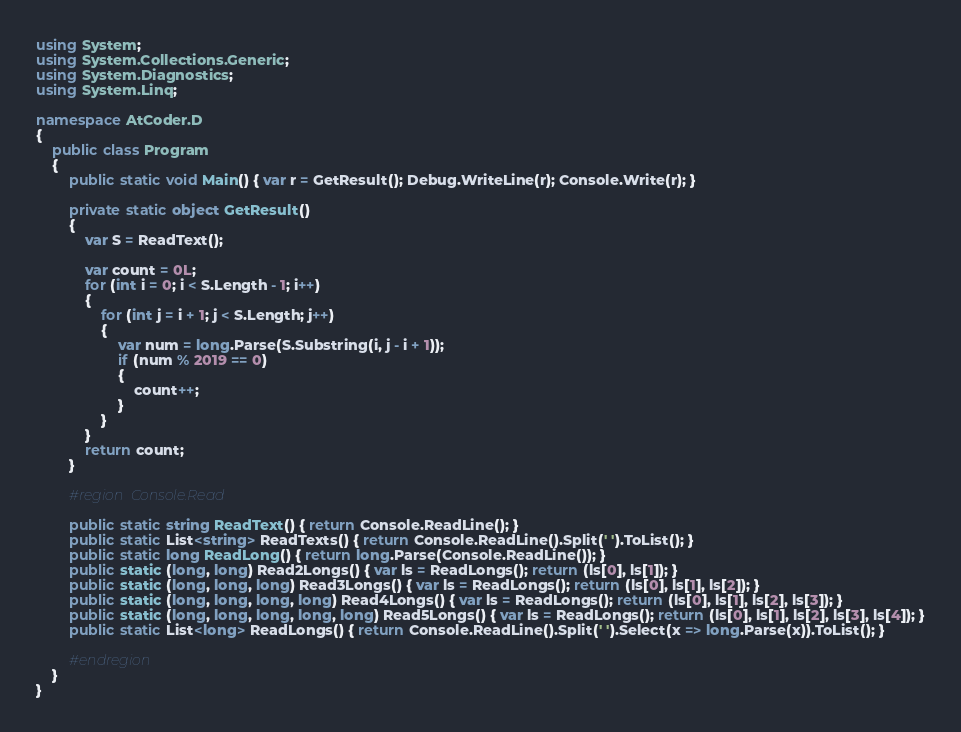<code> <loc_0><loc_0><loc_500><loc_500><_C#_>using System;
using System.Collections.Generic;
using System.Diagnostics;
using System.Linq;

namespace AtCoder.D
{
    public class Program
    {
        public static void Main() { var r = GetResult(); Debug.WriteLine(r); Console.Write(r); }

        private static object GetResult()
        {
            var S = ReadText();

            var count = 0L;
            for (int i = 0; i < S.Length - 1; i++)
            {
                for (int j = i + 1; j < S.Length; j++)
                {
                    var num = long.Parse(S.Substring(i, j - i + 1));
                    if (num % 2019 == 0)
                    {
                        count++;
                    }
                }
            }
            return count;
        }

        #region Console.Read

        public static string ReadText() { return Console.ReadLine(); }
        public static List<string> ReadTexts() { return Console.ReadLine().Split(' ').ToList(); }
        public static long ReadLong() { return long.Parse(Console.ReadLine()); }
        public static (long, long) Read2Longs() { var ls = ReadLongs(); return (ls[0], ls[1]); }
        public static (long, long, long) Read3Longs() { var ls = ReadLongs(); return (ls[0], ls[1], ls[2]); }
        public static (long, long, long, long) Read4Longs() { var ls = ReadLongs(); return (ls[0], ls[1], ls[2], ls[3]); }
        public static (long, long, long, long, long) Read5Longs() { var ls = ReadLongs(); return (ls[0], ls[1], ls[2], ls[3], ls[4]); }
        public static List<long> ReadLongs() { return Console.ReadLine().Split(' ').Select(x => long.Parse(x)).ToList(); }

        #endregion
    }
}
</code> 